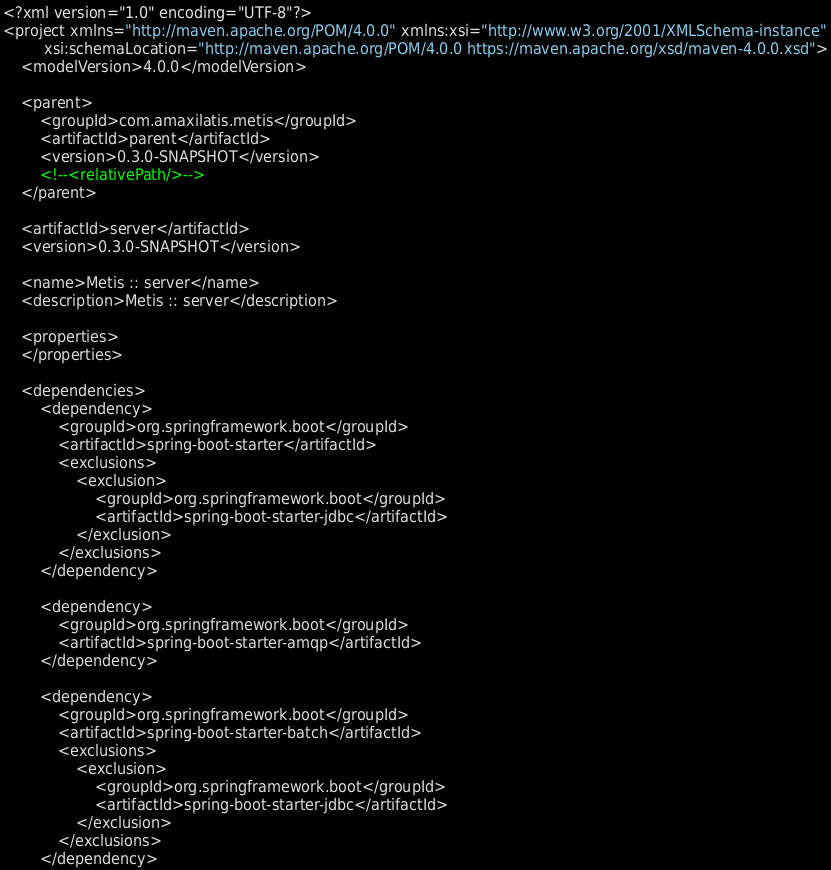Convert code to text. <code><loc_0><loc_0><loc_500><loc_500><_XML_><?xml version="1.0" encoding="UTF-8"?>
<project xmlns="http://maven.apache.org/POM/4.0.0" xmlns:xsi="http://www.w3.org/2001/XMLSchema-instance"
         xsi:schemaLocation="http://maven.apache.org/POM/4.0.0 https://maven.apache.org/xsd/maven-4.0.0.xsd">
    <modelVersion>4.0.0</modelVersion>

    <parent>
        <groupId>com.amaxilatis.metis</groupId>
        <artifactId>parent</artifactId>
        <version>0.3.0-SNAPSHOT</version>
        <!--<relativePath/>-->
    </parent>

    <artifactId>server</artifactId>
    <version>0.3.0-SNAPSHOT</version>

    <name>Metis :: server</name>
    <description>Metis :: server</description>

    <properties>
    </properties>

    <dependencies>
        <dependency>
            <groupId>org.springframework.boot</groupId>
            <artifactId>spring-boot-starter</artifactId>
            <exclusions>
                <exclusion>
                    <groupId>org.springframework.boot</groupId>
                    <artifactId>spring-boot-starter-jdbc</artifactId>
                </exclusion>
            </exclusions>
        </dependency>

        <dependency>
            <groupId>org.springframework.boot</groupId>
            <artifactId>spring-boot-starter-amqp</artifactId>
        </dependency>

        <dependency>
            <groupId>org.springframework.boot</groupId>
            <artifactId>spring-boot-starter-batch</artifactId>
            <exclusions>
                <exclusion>
                    <groupId>org.springframework.boot</groupId>
                    <artifactId>spring-boot-starter-jdbc</artifactId>
                </exclusion>
            </exclusions>
        </dependency>
</code> 